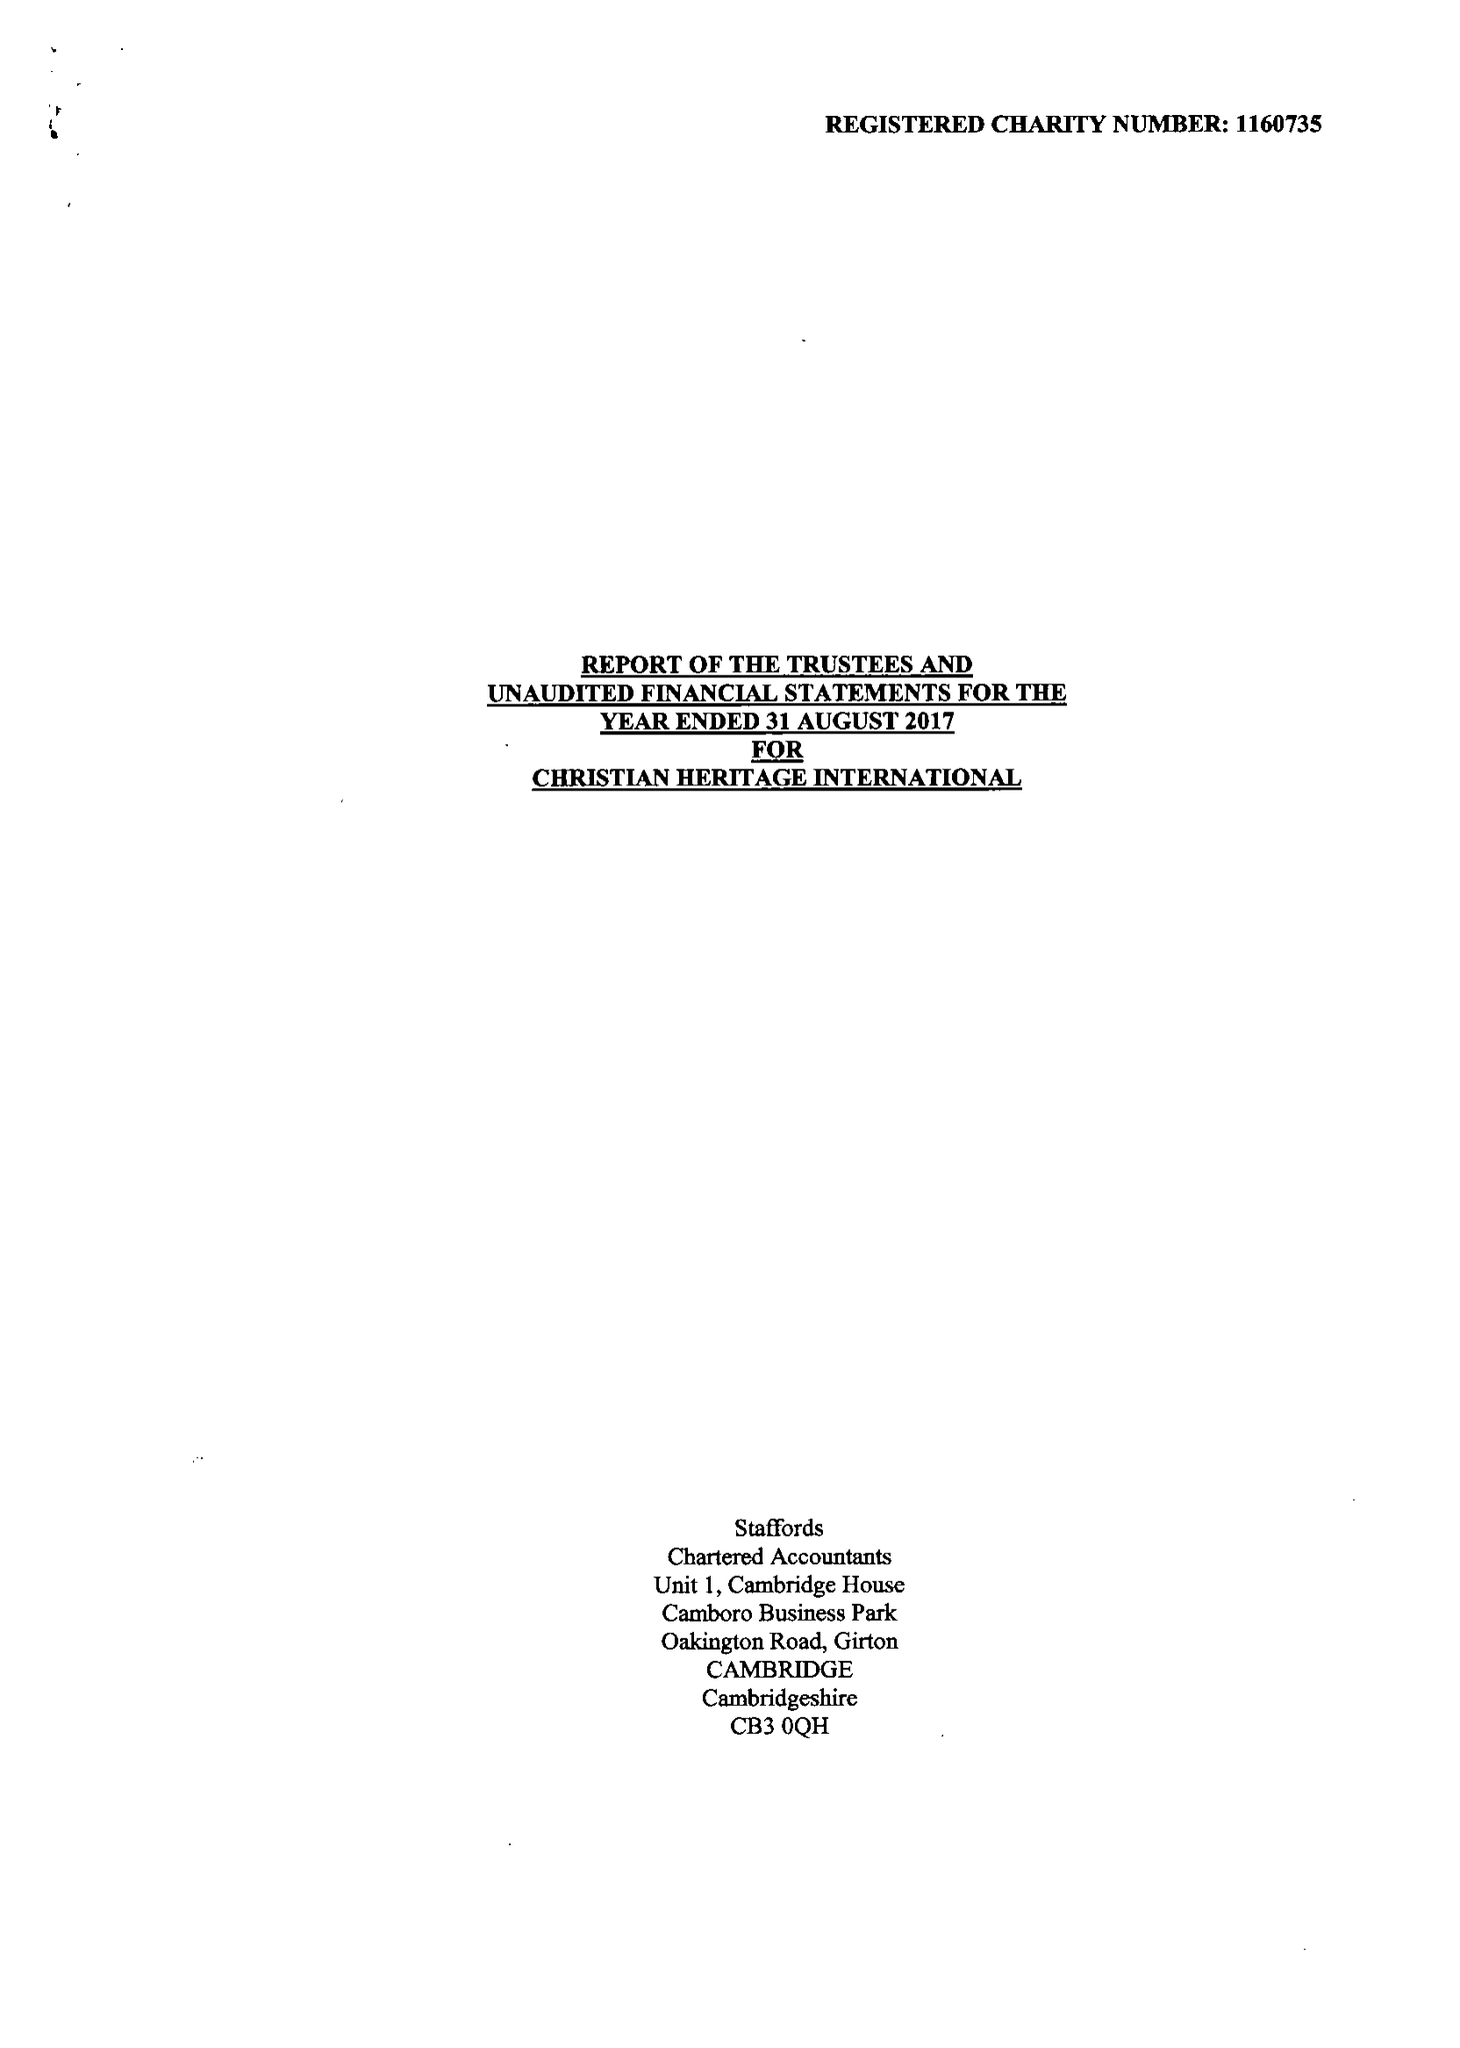What is the value for the spending_annually_in_british_pounds?
Answer the question using a single word or phrase. None 